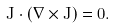<formula> <loc_0><loc_0><loc_500><loc_500>J \cdot ( \nabla \times J ) = 0 .</formula> 